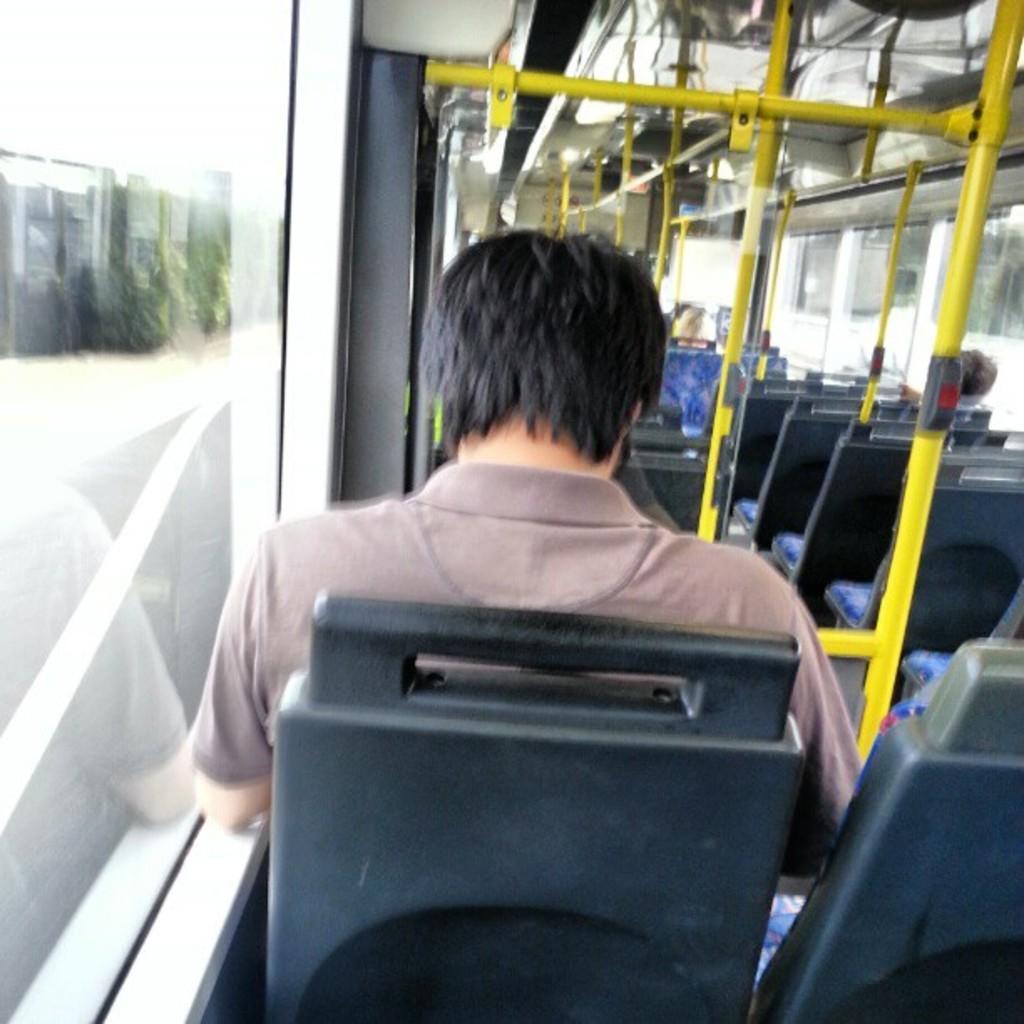Describe this image in one or two sentences. In this image we can see a person sitting in the seat. This image is taken inside a bus. There are seats, rods. To the left side of the image there is glass window, through which we can see road, wall. 